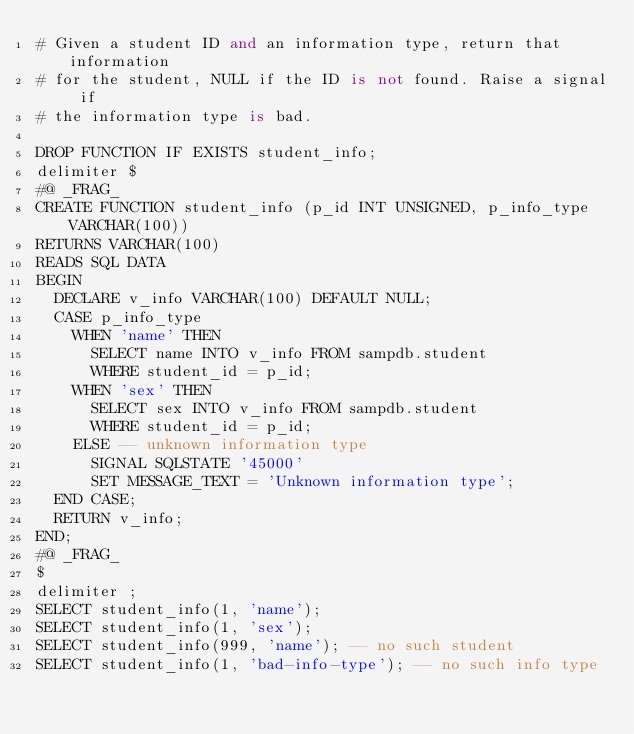<code> <loc_0><loc_0><loc_500><loc_500><_SQL_># Given a student ID and an information type, return that information
# for the student, NULL if the ID is not found. Raise a signal if
# the information type is bad.

DROP FUNCTION IF EXISTS student_info;
delimiter $
#@ _FRAG_
CREATE FUNCTION student_info (p_id INT UNSIGNED, p_info_type VARCHAR(100))
RETURNS VARCHAR(100)
READS SQL DATA
BEGIN
  DECLARE v_info VARCHAR(100) DEFAULT NULL;
  CASE p_info_type
    WHEN 'name' THEN
      SELECT name INTO v_info FROM sampdb.student
      WHERE student_id = p_id;
    WHEN 'sex' THEN
      SELECT sex INTO v_info FROM sampdb.student
      WHERE student_id = p_id;
    ELSE -- unknown information type
      SIGNAL SQLSTATE '45000'
      SET MESSAGE_TEXT = 'Unknown information type';
  END CASE;
  RETURN v_info;
END;
#@ _FRAG_
$
delimiter ;
SELECT student_info(1, 'name');
SELECT student_info(1, 'sex');
SELECT student_info(999, 'name'); -- no such student
SELECT student_info(1, 'bad-info-type'); -- no such info type
</code> 